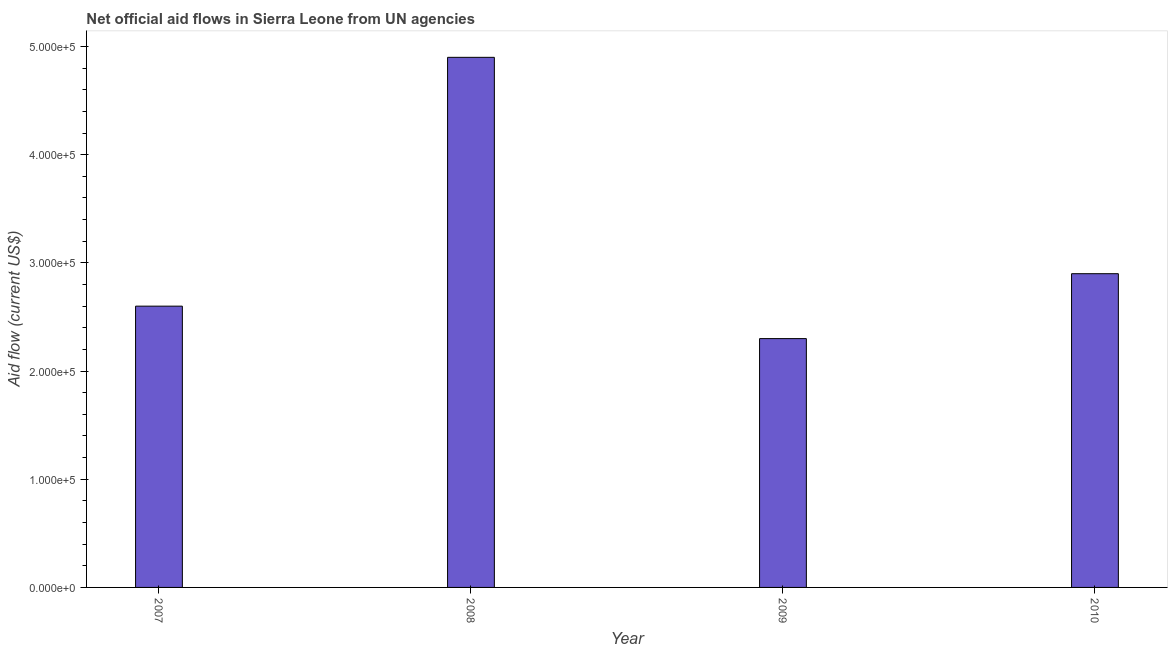Does the graph contain any zero values?
Ensure brevity in your answer.  No. What is the title of the graph?
Your response must be concise. Net official aid flows in Sierra Leone from UN agencies. What is the label or title of the X-axis?
Offer a terse response. Year. What is the label or title of the Y-axis?
Offer a terse response. Aid flow (current US$). What is the net official flows from un agencies in 2010?
Ensure brevity in your answer.  2.90e+05. In which year was the net official flows from un agencies maximum?
Your answer should be compact. 2008. What is the sum of the net official flows from un agencies?
Provide a succinct answer. 1.27e+06. What is the difference between the net official flows from un agencies in 2009 and 2010?
Provide a short and direct response. -6.00e+04. What is the average net official flows from un agencies per year?
Provide a succinct answer. 3.18e+05. What is the median net official flows from un agencies?
Offer a very short reply. 2.75e+05. Do a majority of the years between 2008 and 2007 (inclusive) have net official flows from un agencies greater than 240000 US$?
Give a very brief answer. No. What is the ratio of the net official flows from un agencies in 2007 to that in 2008?
Your response must be concise. 0.53. Is the difference between the net official flows from un agencies in 2009 and 2010 greater than the difference between any two years?
Give a very brief answer. No. How many bars are there?
Your response must be concise. 4. Are all the bars in the graph horizontal?
Your answer should be very brief. No. What is the Aid flow (current US$) in 2010?
Offer a very short reply. 2.90e+05. What is the difference between the Aid flow (current US$) in 2007 and 2008?
Your response must be concise. -2.30e+05. What is the difference between the Aid flow (current US$) in 2007 and 2009?
Your response must be concise. 3.00e+04. What is the difference between the Aid flow (current US$) in 2007 and 2010?
Make the answer very short. -3.00e+04. What is the difference between the Aid flow (current US$) in 2009 and 2010?
Offer a very short reply. -6.00e+04. What is the ratio of the Aid flow (current US$) in 2007 to that in 2008?
Your response must be concise. 0.53. What is the ratio of the Aid flow (current US$) in 2007 to that in 2009?
Your answer should be very brief. 1.13. What is the ratio of the Aid flow (current US$) in 2007 to that in 2010?
Your answer should be very brief. 0.9. What is the ratio of the Aid flow (current US$) in 2008 to that in 2009?
Ensure brevity in your answer.  2.13. What is the ratio of the Aid flow (current US$) in 2008 to that in 2010?
Your response must be concise. 1.69. What is the ratio of the Aid flow (current US$) in 2009 to that in 2010?
Your response must be concise. 0.79. 